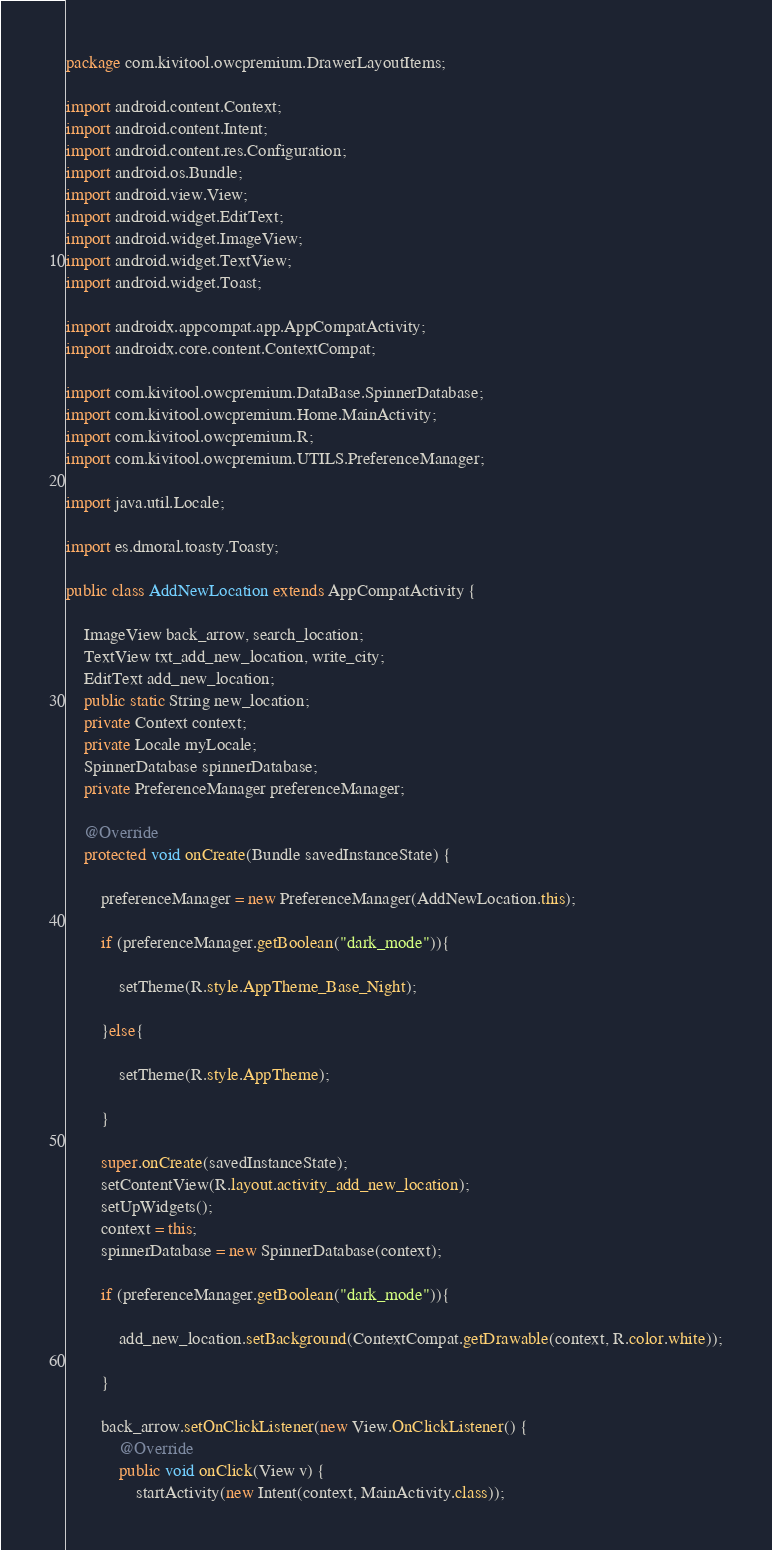<code> <loc_0><loc_0><loc_500><loc_500><_Java_>package com.kivitool.owcpremium.DrawerLayoutItems;

import android.content.Context;
import android.content.Intent;
import android.content.res.Configuration;
import android.os.Bundle;
import android.view.View;
import android.widget.EditText;
import android.widget.ImageView;
import android.widget.TextView;
import android.widget.Toast;

import androidx.appcompat.app.AppCompatActivity;
import androidx.core.content.ContextCompat;

import com.kivitool.owcpremium.DataBase.SpinnerDatabase;
import com.kivitool.owcpremium.Home.MainActivity;
import com.kivitool.owcpremium.R;
import com.kivitool.owcpremium.UTILS.PreferenceManager;

import java.util.Locale;

import es.dmoral.toasty.Toasty;

public class AddNewLocation extends AppCompatActivity {

    ImageView back_arrow, search_location;
    TextView txt_add_new_location, write_city;
    EditText add_new_location;
    public static String new_location;
    private Context context;
    private Locale myLocale;
    SpinnerDatabase spinnerDatabase;
    private PreferenceManager preferenceManager;

    @Override
    protected void onCreate(Bundle savedInstanceState) {

        preferenceManager = new PreferenceManager(AddNewLocation.this);

        if (preferenceManager.getBoolean("dark_mode")){

            setTheme(R.style.AppTheme_Base_Night);

        }else{

            setTheme(R.style.AppTheme);

        }

        super.onCreate(savedInstanceState);
        setContentView(R.layout.activity_add_new_location);
        setUpWidgets();
        context = this;
        spinnerDatabase = new SpinnerDatabase(context);

        if (preferenceManager.getBoolean("dark_mode")){

            add_new_location.setBackground(ContextCompat.getDrawable(context, R.color.white));

        }

        back_arrow.setOnClickListener(new View.OnClickListener() {
            @Override
            public void onClick(View v) {
                startActivity(new Intent(context, MainActivity.class));</code> 